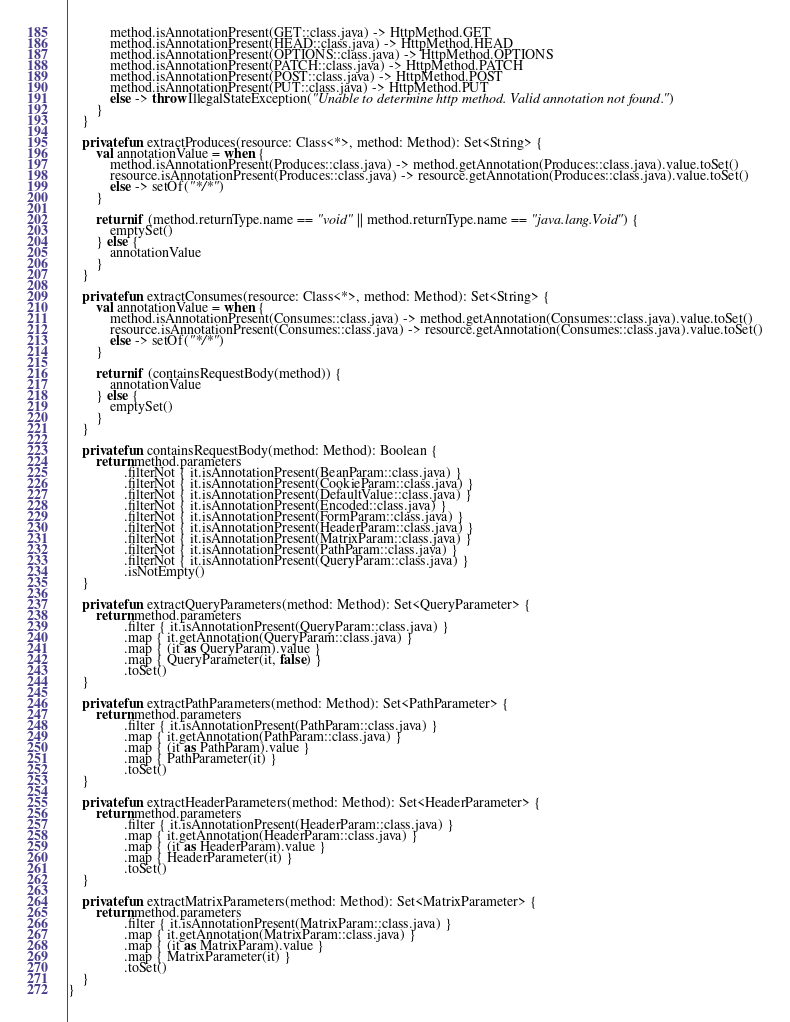<code> <loc_0><loc_0><loc_500><loc_500><_Kotlin_>            method.isAnnotationPresent(GET::class.java) -> HttpMethod.GET
            method.isAnnotationPresent(HEAD::class.java) -> HttpMethod.HEAD
            method.isAnnotationPresent(OPTIONS::class.java) -> HttpMethod.OPTIONS
            method.isAnnotationPresent(PATCH::class.java) -> HttpMethod.PATCH
            method.isAnnotationPresent(POST::class.java) -> HttpMethod.POST
            method.isAnnotationPresent(PUT::class.java) -> HttpMethod.PUT
            else -> throw IllegalStateException("Unable to determine http method. Valid annotation not found.")
        }
    }

    private fun extractProduces(resource: Class<*>, method: Method): Set<String> {
        val annotationValue = when {
            method.isAnnotationPresent(Produces::class.java) -> method.getAnnotation(Produces::class.java).value.toSet()
            resource.isAnnotationPresent(Produces::class.java) -> resource.getAnnotation(Produces::class.java).value.toSet()
            else -> setOf("*/*")
        }

        return if (method.returnType.name == "void" || method.returnType.name == "java.lang.Void") {
            emptySet()
        } else {
            annotationValue
        }
    }

    private fun extractConsumes(resource: Class<*>, method: Method): Set<String> {
        val annotationValue = when {
            method.isAnnotationPresent(Consumes::class.java) -> method.getAnnotation(Consumes::class.java).value.toSet()
            resource.isAnnotationPresent(Consumes::class.java) -> resource.getAnnotation(Consumes::class.java).value.toSet()
            else -> setOf("*/*")
        }

        return if (containsRequestBody(method)) {
            annotationValue
        } else {
            emptySet()
        }
    }

    private fun containsRequestBody(method: Method): Boolean {
        return method.parameters
                .filterNot { it.isAnnotationPresent(BeanParam::class.java) }
                .filterNot { it.isAnnotationPresent(CookieParam::class.java) }
                .filterNot { it.isAnnotationPresent(DefaultValue::class.java) }
                .filterNot { it.isAnnotationPresent(Encoded::class.java) }
                .filterNot { it.isAnnotationPresent(FormParam::class.java) }
                .filterNot { it.isAnnotationPresent(HeaderParam::class.java) }
                .filterNot { it.isAnnotationPresent(MatrixParam::class.java) }
                .filterNot { it.isAnnotationPresent(PathParam::class.java) }
                .filterNot { it.isAnnotationPresent(QueryParam::class.java) }
                .isNotEmpty()
    }

    private fun extractQueryParameters(method: Method): Set<QueryParameter> {
        return method.parameters
                .filter { it.isAnnotationPresent(QueryParam::class.java) }
                .map { it.getAnnotation(QueryParam::class.java) }
                .map { (it as QueryParam).value }
                .map { QueryParameter(it, false) }
                .toSet()
    }

    private fun extractPathParameters(method: Method): Set<PathParameter> {
        return method.parameters
                .filter { it.isAnnotationPresent(PathParam::class.java) }
                .map { it.getAnnotation(PathParam::class.java) }
                .map { (it as PathParam).value }
                .map { PathParameter(it) }
                .toSet()
    }

    private fun extractHeaderParameters(method: Method): Set<HeaderParameter> {
        return method.parameters
                .filter { it.isAnnotationPresent(HeaderParam::class.java) }
                .map { it.getAnnotation(HeaderParam::class.java) }
                .map { (it as HeaderParam).value }
                .map { HeaderParameter(it) }
                .toSet()
    }

    private fun extractMatrixParameters(method: Method): Set<MatrixParameter> {
        return method.parameters
                .filter { it.isAnnotationPresent(MatrixParam::class.java) }
                .map { it.getAnnotation(MatrixParam::class.java) }
                .map { (it as MatrixParam).value }
                .map { MatrixParameter(it) }
                .toSet()
    }
}</code> 